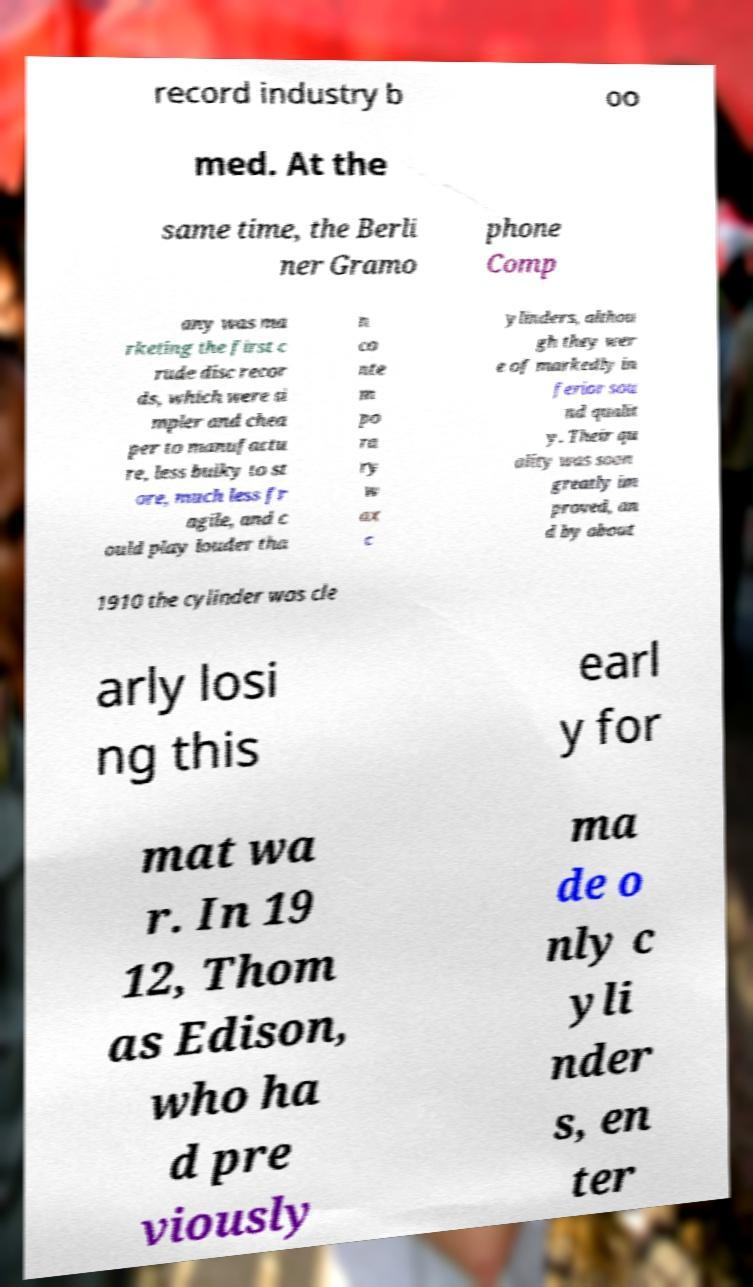Could you extract and type out the text from this image? record industry b oo med. At the same time, the Berli ner Gramo phone Comp any was ma rketing the first c rude disc recor ds, which were si mpler and chea per to manufactu re, less bulky to st ore, much less fr agile, and c ould play louder tha n co nte m po ra ry w ax c ylinders, althou gh they wer e of markedly in ferior sou nd qualit y. Their qu ality was soon greatly im proved, an d by about 1910 the cylinder was cle arly losi ng this earl y for mat wa r. In 19 12, Thom as Edison, who ha d pre viously ma de o nly c yli nder s, en ter 